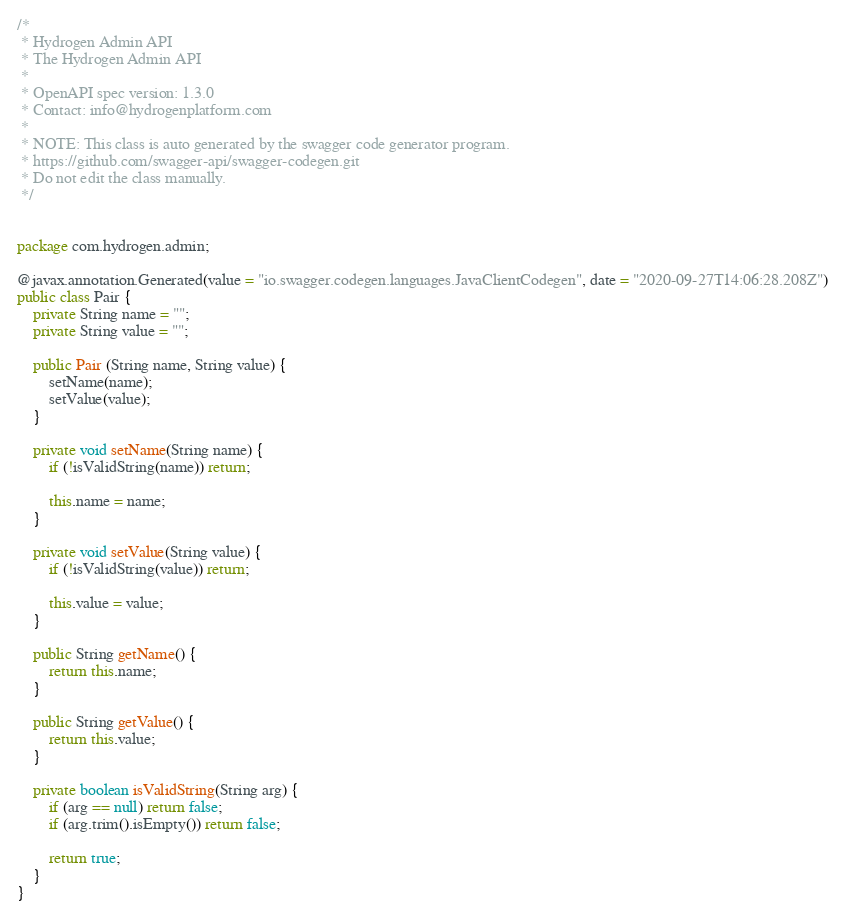<code> <loc_0><loc_0><loc_500><loc_500><_Java_>/*
 * Hydrogen Admin API
 * The Hydrogen Admin API
 *
 * OpenAPI spec version: 1.3.0
 * Contact: info@hydrogenplatform.com
 *
 * NOTE: This class is auto generated by the swagger code generator program.
 * https://github.com/swagger-api/swagger-codegen.git
 * Do not edit the class manually.
 */


package com.hydrogen.admin;

@javax.annotation.Generated(value = "io.swagger.codegen.languages.JavaClientCodegen", date = "2020-09-27T14:06:28.208Z")
public class Pair {
    private String name = "";
    private String value = "";

    public Pair (String name, String value) {
        setName(name);
        setValue(value);
    }

    private void setName(String name) {
        if (!isValidString(name)) return;

        this.name = name;
    }

    private void setValue(String value) {
        if (!isValidString(value)) return;

        this.value = value;
    }

    public String getName() {
        return this.name;
    }

    public String getValue() {
        return this.value;
    }

    private boolean isValidString(String arg) {
        if (arg == null) return false;
        if (arg.trim().isEmpty()) return false;

        return true;
    }
}
</code> 